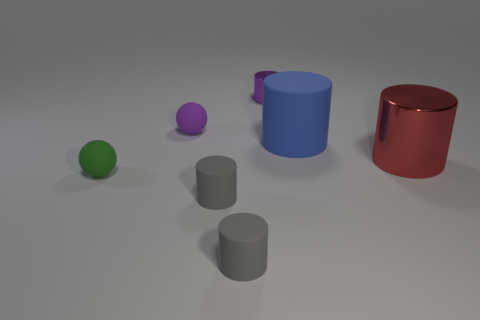What is the material of the big red cylinder?
Give a very brief answer. Metal. What number of large objects are either green things or gray cubes?
Offer a very short reply. 0. How many objects are behind the small green thing?
Your answer should be compact. 4. Is there a large metallic cylinder of the same color as the tiny metal cylinder?
Your answer should be very brief. No. The other metal object that is the same size as the green object is what shape?
Your response must be concise. Cylinder. What number of yellow things are tiny metal cylinders or large matte cylinders?
Give a very brief answer. 0. What number of blue things have the same size as the green rubber thing?
Your response must be concise. 0. There is a matte thing that is the same color as the tiny metallic object; what shape is it?
Your answer should be very brief. Sphere. How many objects are either green matte objects or small rubber things right of the purple matte object?
Offer a very short reply. 3. There is a metallic object in front of the tiny shiny object; is it the same size as the metal thing behind the large blue object?
Provide a short and direct response. No. 